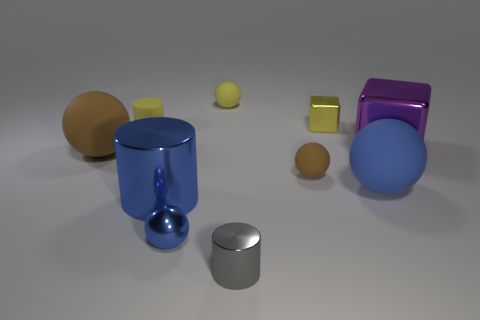Subtract all small cylinders. How many cylinders are left? 1 Subtract all cylinders. How many objects are left? 7 Subtract 2 cylinders. How many cylinders are left? 1 Subtract all blue cylinders. How many cylinders are left? 2 Subtract all large shiny things. Subtract all big red blocks. How many objects are left? 8 Add 9 blue rubber spheres. How many blue rubber spheres are left? 10 Add 10 small purple cylinders. How many small purple cylinders exist? 10 Subtract 0 red cylinders. How many objects are left? 10 Subtract all green cylinders. Subtract all gray spheres. How many cylinders are left? 3 Subtract all green cylinders. How many yellow spheres are left? 1 